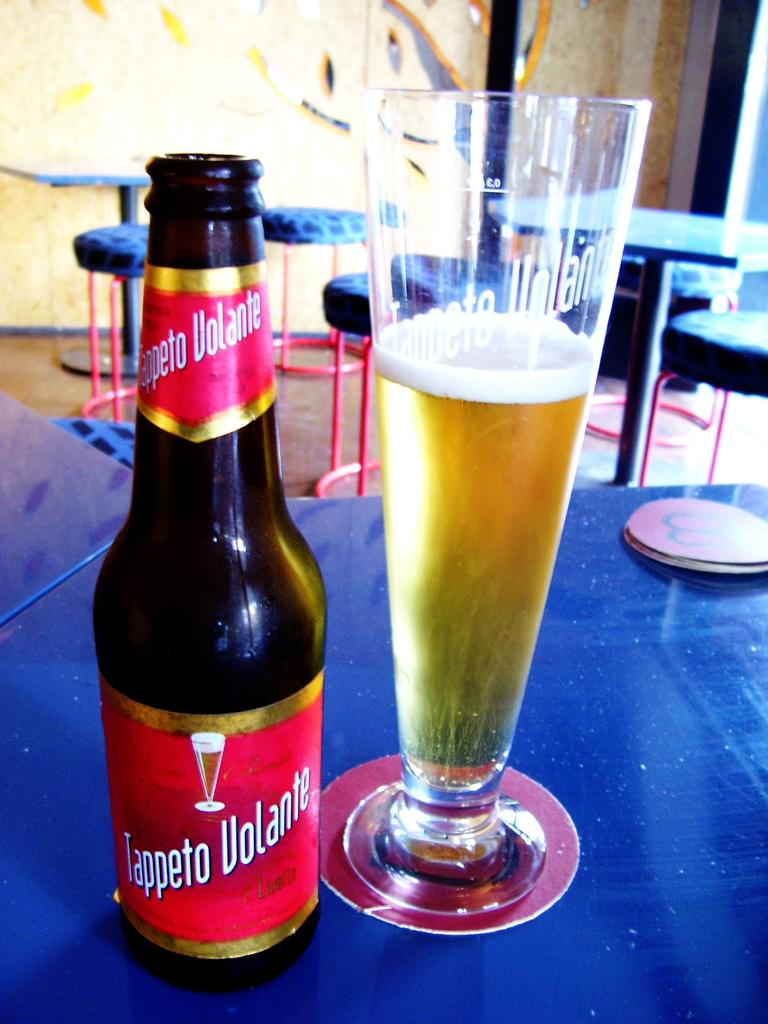<image>
Describe the image concisely. A bottle of Tappeto Volante beer is next to a glass with beer in it. 